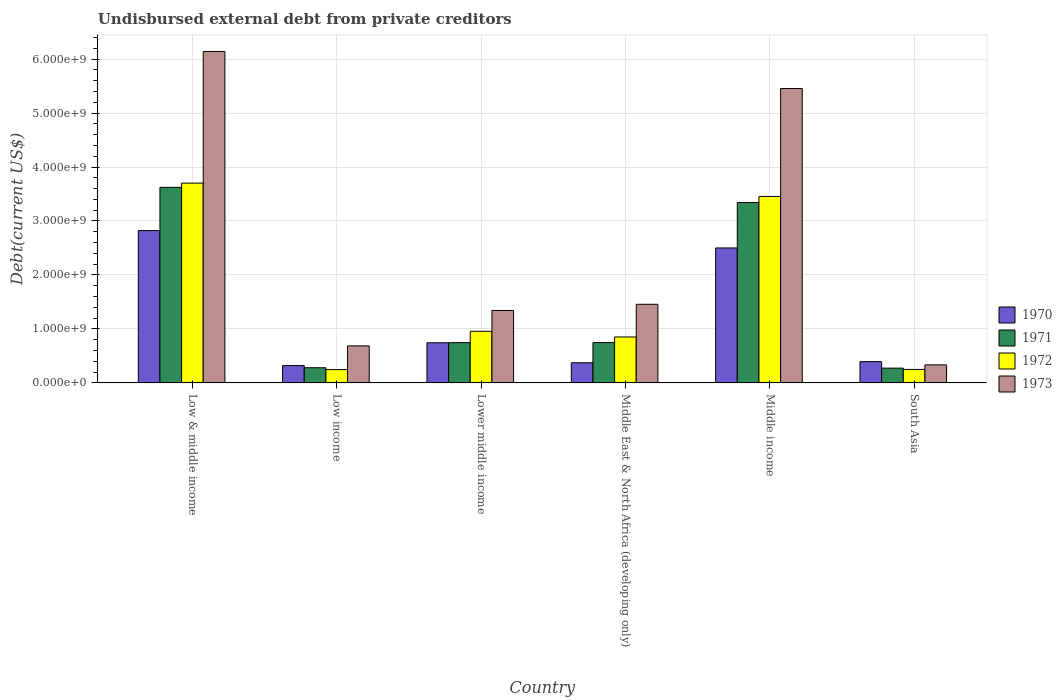How many different coloured bars are there?
Offer a very short reply. 4. How many bars are there on the 5th tick from the left?
Keep it short and to the point. 4. What is the label of the 3rd group of bars from the left?
Ensure brevity in your answer.  Lower middle income. In how many cases, is the number of bars for a given country not equal to the number of legend labels?
Give a very brief answer. 0. What is the total debt in 1972 in Low income?
Offer a terse response. 2.47e+08. Across all countries, what is the maximum total debt in 1973?
Provide a short and direct response. 6.14e+09. Across all countries, what is the minimum total debt in 1971?
Keep it short and to the point. 2.74e+08. In which country was the total debt in 1972 maximum?
Provide a succinct answer. Low & middle income. In which country was the total debt in 1970 minimum?
Offer a very short reply. Low income. What is the total total debt in 1971 in the graph?
Provide a succinct answer. 9.01e+09. What is the difference between the total debt in 1973 in Middle income and that in South Asia?
Your answer should be very brief. 5.12e+09. What is the difference between the total debt in 1971 in Low income and the total debt in 1973 in Middle East & North Africa (developing only)?
Ensure brevity in your answer.  -1.18e+09. What is the average total debt in 1970 per country?
Ensure brevity in your answer.  1.19e+09. What is the difference between the total debt of/in 1970 and total debt of/in 1972 in Low & middle income?
Provide a succinct answer. -8.79e+08. In how many countries, is the total debt in 1971 greater than 2000000000 US$?
Make the answer very short. 2. What is the ratio of the total debt in 1971 in Middle East & North Africa (developing only) to that in South Asia?
Provide a succinct answer. 2.73. Is the total debt in 1972 in Lower middle income less than that in Middle East & North Africa (developing only)?
Make the answer very short. No. What is the difference between the highest and the second highest total debt in 1970?
Your response must be concise. 2.08e+09. What is the difference between the highest and the lowest total debt in 1970?
Keep it short and to the point. 2.50e+09. Is the sum of the total debt in 1971 in Lower middle income and South Asia greater than the maximum total debt in 1972 across all countries?
Give a very brief answer. No. Is it the case that in every country, the sum of the total debt in 1972 and total debt in 1970 is greater than the sum of total debt in 1971 and total debt in 1973?
Your answer should be compact. No. What does the 1st bar from the right in Middle East & North Africa (developing only) represents?
Your answer should be compact. 1973. Is it the case that in every country, the sum of the total debt in 1971 and total debt in 1973 is greater than the total debt in 1972?
Offer a terse response. Yes. Are all the bars in the graph horizontal?
Make the answer very short. No. How many countries are there in the graph?
Provide a succinct answer. 6. Are the values on the major ticks of Y-axis written in scientific E-notation?
Your answer should be very brief. Yes. Does the graph contain grids?
Provide a succinct answer. Yes. What is the title of the graph?
Your response must be concise. Undisbursed external debt from private creditors. Does "1973" appear as one of the legend labels in the graph?
Offer a terse response. Yes. What is the label or title of the X-axis?
Provide a short and direct response. Country. What is the label or title of the Y-axis?
Ensure brevity in your answer.  Debt(current US$). What is the Debt(current US$) in 1970 in Low & middle income?
Provide a succinct answer. 2.82e+09. What is the Debt(current US$) in 1971 in Low & middle income?
Ensure brevity in your answer.  3.62e+09. What is the Debt(current US$) in 1972 in Low & middle income?
Your response must be concise. 3.70e+09. What is the Debt(current US$) of 1973 in Low & middle income?
Your response must be concise. 6.14e+09. What is the Debt(current US$) of 1970 in Low income?
Make the answer very short. 3.22e+08. What is the Debt(current US$) in 1971 in Low income?
Your response must be concise. 2.82e+08. What is the Debt(current US$) of 1972 in Low income?
Provide a short and direct response. 2.47e+08. What is the Debt(current US$) of 1973 in Low income?
Your answer should be very brief. 6.86e+08. What is the Debt(current US$) in 1970 in Lower middle income?
Your answer should be compact. 7.44e+08. What is the Debt(current US$) in 1971 in Lower middle income?
Offer a very short reply. 7.46e+08. What is the Debt(current US$) in 1972 in Lower middle income?
Offer a terse response. 9.57e+08. What is the Debt(current US$) in 1973 in Lower middle income?
Make the answer very short. 1.34e+09. What is the Debt(current US$) in 1970 in Middle East & North Africa (developing only)?
Keep it short and to the point. 3.74e+08. What is the Debt(current US$) of 1971 in Middle East & North Africa (developing only)?
Make the answer very short. 7.48e+08. What is the Debt(current US$) of 1972 in Middle East & North Africa (developing only)?
Make the answer very short. 8.51e+08. What is the Debt(current US$) in 1973 in Middle East & North Africa (developing only)?
Offer a terse response. 1.46e+09. What is the Debt(current US$) in 1970 in Middle income?
Ensure brevity in your answer.  2.50e+09. What is the Debt(current US$) in 1971 in Middle income?
Ensure brevity in your answer.  3.34e+09. What is the Debt(current US$) of 1972 in Middle income?
Your answer should be compact. 3.45e+09. What is the Debt(current US$) of 1973 in Middle income?
Provide a succinct answer. 5.45e+09. What is the Debt(current US$) of 1970 in South Asia?
Provide a succinct answer. 3.94e+08. What is the Debt(current US$) in 1971 in South Asia?
Make the answer very short. 2.74e+08. What is the Debt(current US$) in 1972 in South Asia?
Ensure brevity in your answer.  2.50e+08. What is the Debt(current US$) in 1973 in South Asia?
Your answer should be compact. 3.35e+08. Across all countries, what is the maximum Debt(current US$) in 1970?
Your answer should be compact. 2.82e+09. Across all countries, what is the maximum Debt(current US$) in 1971?
Offer a very short reply. 3.62e+09. Across all countries, what is the maximum Debt(current US$) of 1972?
Keep it short and to the point. 3.70e+09. Across all countries, what is the maximum Debt(current US$) in 1973?
Your response must be concise. 6.14e+09. Across all countries, what is the minimum Debt(current US$) of 1970?
Offer a very short reply. 3.22e+08. Across all countries, what is the minimum Debt(current US$) of 1971?
Ensure brevity in your answer.  2.74e+08. Across all countries, what is the minimum Debt(current US$) of 1972?
Your answer should be very brief. 2.47e+08. Across all countries, what is the minimum Debt(current US$) of 1973?
Ensure brevity in your answer.  3.35e+08. What is the total Debt(current US$) of 1970 in the graph?
Your answer should be compact. 7.16e+09. What is the total Debt(current US$) of 1971 in the graph?
Your answer should be very brief. 9.01e+09. What is the total Debt(current US$) in 1972 in the graph?
Offer a terse response. 9.46e+09. What is the total Debt(current US$) in 1973 in the graph?
Offer a very short reply. 1.54e+1. What is the difference between the Debt(current US$) in 1970 in Low & middle income and that in Low income?
Offer a very short reply. 2.50e+09. What is the difference between the Debt(current US$) in 1971 in Low & middle income and that in Low income?
Make the answer very short. 3.34e+09. What is the difference between the Debt(current US$) in 1972 in Low & middle income and that in Low income?
Your response must be concise. 3.45e+09. What is the difference between the Debt(current US$) of 1973 in Low & middle income and that in Low income?
Give a very brief answer. 5.45e+09. What is the difference between the Debt(current US$) in 1970 in Low & middle income and that in Lower middle income?
Provide a short and direct response. 2.08e+09. What is the difference between the Debt(current US$) of 1971 in Low & middle income and that in Lower middle income?
Offer a very short reply. 2.88e+09. What is the difference between the Debt(current US$) in 1972 in Low & middle income and that in Lower middle income?
Provide a short and direct response. 2.74e+09. What is the difference between the Debt(current US$) in 1973 in Low & middle income and that in Lower middle income?
Give a very brief answer. 4.80e+09. What is the difference between the Debt(current US$) in 1970 in Low & middle income and that in Middle East & North Africa (developing only)?
Provide a short and direct response. 2.45e+09. What is the difference between the Debt(current US$) of 1971 in Low & middle income and that in Middle East & North Africa (developing only)?
Make the answer very short. 2.88e+09. What is the difference between the Debt(current US$) in 1972 in Low & middle income and that in Middle East & North Africa (developing only)?
Your answer should be compact. 2.85e+09. What is the difference between the Debt(current US$) in 1973 in Low & middle income and that in Middle East & North Africa (developing only)?
Keep it short and to the point. 4.68e+09. What is the difference between the Debt(current US$) of 1970 in Low & middle income and that in Middle income?
Offer a very short reply. 3.22e+08. What is the difference between the Debt(current US$) in 1971 in Low & middle income and that in Middle income?
Your answer should be very brief. 2.82e+08. What is the difference between the Debt(current US$) of 1972 in Low & middle income and that in Middle income?
Offer a terse response. 2.47e+08. What is the difference between the Debt(current US$) of 1973 in Low & middle income and that in Middle income?
Make the answer very short. 6.86e+08. What is the difference between the Debt(current US$) in 1970 in Low & middle income and that in South Asia?
Give a very brief answer. 2.43e+09. What is the difference between the Debt(current US$) in 1971 in Low & middle income and that in South Asia?
Provide a short and direct response. 3.35e+09. What is the difference between the Debt(current US$) in 1972 in Low & middle income and that in South Asia?
Your response must be concise. 3.45e+09. What is the difference between the Debt(current US$) of 1973 in Low & middle income and that in South Asia?
Offer a very short reply. 5.81e+09. What is the difference between the Debt(current US$) in 1970 in Low income and that in Lower middle income?
Give a very brief answer. -4.22e+08. What is the difference between the Debt(current US$) of 1971 in Low income and that in Lower middle income?
Keep it short and to the point. -4.65e+08. What is the difference between the Debt(current US$) in 1972 in Low income and that in Lower middle income?
Ensure brevity in your answer.  -7.10e+08. What is the difference between the Debt(current US$) of 1973 in Low income and that in Lower middle income?
Provide a succinct answer. -6.56e+08. What is the difference between the Debt(current US$) of 1970 in Low income and that in Middle East & North Africa (developing only)?
Keep it short and to the point. -5.15e+07. What is the difference between the Debt(current US$) in 1971 in Low income and that in Middle East & North Africa (developing only)?
Provide a succinct answer. -4.66e+08. What is the difference between the Debt(current US$) in 1972 in Low income and that in Middle East & North Africa (developing only)?
Your answer should be very brief. -6.05e+08. What is the difference between the Debt(current US$) of 1973 in Low income and that in Middle East & North Africa (developing only)?
Make the answer very short. -7.71e+08. What is the difference between the Debt(current US$) in 1970 in Low income and that in Middle income?
Ensure brevity in your answer.  -2.18e+09. What is the difference between the Debt(current US$) of 1971 in Low income and that in Middle income?
Provide a succinct answer. -3.06e+09. What is the difference between the Debt(current US$) of 1972 in Low income and that in Middle income?
Make the answer very short. -3.21e+09. What is the difference between the Debt(current US$) in 1973 in Low income and that in Middle income?
Your response must be concise. -4.77e+09. What is the difference between the Debt(current US$) of 1970 in Low income and that in South Asia?
Keep it short and to the point. -7.22e+07. What is the difference between the Debt(current US$) of 1971 in Low income and that in South Asia?
Your answer should be very brief. 7.14e+06. What is the difference between the Debt(current US$) in 1972 in Low income and that in South Asia?
Provide a short and direct response. -3.44e+06. What is the difference between the Debt(current US$) in 1973 in Low income and that in South Asia?
Your answer should be very brief. 3.52e+08. What is the difference between the Debt(current US$) of 1970 in Lower middle income and that in Middle East & North Africa (developing only)?
Provide a short and direct response. 3.71e+08. What is the difference between the Debt(current US$) in 1971 in Lower middle income and that in Middle East & North Africa (developing only)?
Your response must be concise. -1.62e+06. What is the difference between the Debt(current US$) of 1972 in Lower middle income and that in Middle East & North Africa (developing only)?
Provide a succinct answer. 1.05e+08. What is the difference between the Debt(current US$) of 1973 in Lower middle income and that in Middle East & North Africa (developing only)?
Your answer should be very brief. -1.14e+08. What is the difference between the Debt(current US$) in 1970 in Lower middle income and that in Middle income?
Give a very brief answer. -1.76e+09. What is the difference between the Debt(current US$) of 1971 in Lower middle income and that in Middle income?
Your answer should be very brief. -2.60e+09. What is the difference between the Debt(current US$) in 1972 in Lower middle income and that in Middle income?
Offer a terse response. -2.50e+09. What is the difference between the Debt(current US$) in 1973 in Lower middle income and that in Middle income?
Provide a short and direct response. -4.11e+09. What is the difference between the Debt(current US$) of 1970 in Lower middle income and that in South Asia?
Your answer should be compact. 3.50e+08. What is the difference between the Debt(current US$) in 1971 in Lower middle income and that in South Asia?
Your answer should be very brief. 4.72e+08. What is the difference between the Debt(current US$) of 1972 in Lower middle income and that in South Asia?
Provide a short and direct response. 7.07e+08. What is the difference between the Debt(current US$) in 1973 in Lower middle income and that in South Asia?
Offer a very short reply. 1.01e+09. What is the difference between the Debt(current US$) in 1970 in Middle East & North Africa (developing only) and that in Middle income?
Keep it short and to the point. -2.13e+09. What is the difference between the Debt(current US$) in 1971 in Middle East & North Africa (developing only) and that in Middle income?
Offer a terse response. -2.59e+09. What is the difference between the Debt(current US$) of 1972 in Middle East & North Africa (developing only) and that in Middle income?
Your answer should be very brief. -2.60e+09. What is the difference between the Debt(current US$) in 1973 in Middle East & North Africa (developing only) and that in Middle income?
Give a very brief answer. -4.00e+09. What is the difference between the Debt(current US$) of 1970 in Middle East & North Africa (developing only) and that in South Asia?
Give a very brief answer. -2.07e+07. What is the difference between the Debt(current US$) of 1971 in Middle East & North Africa (developing only) and that in South Asia?
Provide a short and direct response. 4.74e+08. What is the difference between the Debt(current US$) of 1972 in Middle East & North Africa (developing only) and that in South Asia?
Provide a succinct answer. 6.01e+08. What is the difference between the Debt(current US$) in 1973 in Middle East & North Africa (developing only) and that in South Asia?
Offer a terse response. 1.12e+09. What is the difference between the Debt(current US$) of 1970 in Middle income and that in South Asia?
Provide a succinct answer. 2.11e+09. What is the difference between the Debt(current US$) in 1971 in Middle income and that in South Asia?
Ensure brevity in your answer.  3.07e+09. What is the difference between the Debt(current US$) in 1972 in Middle income and that in South Asia?
Provide a succinct answer. 3.20e+09. What is the difference between the Debt(current US$) of 1973 in Middle income and that in South Asia?
Your answer should be very brief. 5.12e+09. What is the difference between the Debt(current US$) of 1970 in Low & middle income and the Debt(current US$) of 1971 in Low income?
Keep it short and to the point. 2.54e+09. What is the difference between the Debt(current US$) in 1970 in Low & middle income and the Debt(current US$) in 1972 in Low income?
Your response must be concise. 2.58e+09. What is the difference between the Debt(current US$) in 1970 in Low & middle income and the Debt(current US$) in 1973 in Low income?
Provide a short and direct response. 2.14e+09. What is the difference between the Debt(current US$) of 1971 in Low & middle income and the Debt(current US$) of 1972 in Low income?
Your answer should be very brief. 3.38e+09. What is the difference between the Debt(current US$) of 1971 in Low & middle income and the Debt(current US$) of 1973 in Low income?
Make the answer very short. 2.94e+09. What is the difference between the Debt(current US$) of 1972 in Low & middle income and the Debt(current US$) of 1973 in Low income?
Provide a succinct answer. 3.02e+09. What is the difference between the Debt(current US$) in 1970 in Low & middle income and the Debt(current US$) in 1971 in Lower middle income?
Your response must be concise. 2.08e+09. What is the difference between the Debt(current US$) of 1970 in Low & middle income and the Debt(current US$) of 1972 in Lower middle income?
Provide a succinct answer. 1.87e+09. What is the difference between the Debt(current US$) of 1970 in Low & middle income and the Debt(current US$) of 1973 in Lower middle income?
Ensure brevity in your answer.  1.48e+09. What is the difference between the Debt(current US$) of 1971 in Low & middle income and the Debt(current US$) of 1972 in Lower middle income?
Provide a short and direct response. 2.67e+09. What is the difference between the Debt(current US$) in 1971 in Low & middle income and the Debt(current US$) in 1973 in Lower middle income?
Your answer should be very brief. 2.28e+09. What is the difference between the Debt(current US$) of 1972 in Low & middle income and the Debt(current US$) of 1973 in Lower middle income?
Make the answer very short. 2.36e+09. What is the difference between the Debt(current US$) in 1970 in Low & middle income and the Debt(current US$) in 1971 in Middle East & North Africa (developing only)?
Your answer should be compact. 2.07e+09. What is the difference between the Debt(current US$) in 1970 in Low & middle income and the Debt(current US$) in 1972 in Middle East & North Africa (developing only)?
Offer a terse response. 1.97e+09. What is the difference between the Debt(current US$) of 1970 in Low & middle income and the Debt(current US$) of 1973 in Middle East & North Africa (developing only)?
Your answer should be very brief. 1.37e+09. What is the difference between the Debt(current US$) in 1971 in Low & middle income and the Debt(current US$) in 1972 in Middle East & North Africa (developing only)?
Offer a very short reply. 2.77e+09. What is the difference between the Debt(current US$) of 1971 in Low & middle income and the Debt(current US$) of 1973 in Middle East & North Africa (developing only)?
Offer a terse response. 2.17e+09. What is the difference between the Debt(current US$) in 1972 in Low & middle income and the Debt(current US$) in 1973 in Middle East & North Africa (developing only)?
Ensure brevity in your answer.  2.24e+09. What is the difference between the Debt(current US$) in 1970 in Low & middle income and the Debt(current US$) in 1971 in Middle income?
Offer a terse response. -5.19e+08. What is the difference between the Debt(current US$) of 1970 in Low & middle income and the Debt(current US$) of 1972 in Middle income?
Offer a terse response. -6.32e+08. What is the difference between the Debt(current US$) of 1970 in Low & middle income and the Debt(current US$) of 1973 in Middle income?
Keep it short and to the point. -2.63e+09. What is the difference between the Debt(current US$) in 1971 in Low & middle income and the Debt(current US$) in 1972 in Middle income?
Make the answer very short. 1.68e+08. What is the difference between the Debt(current US$) of 1971 in Low & middle income and the Debt(current US$) of 1973 in Middle income?
Give a very brief answer. -1.83e+09. What is the difference between the Debt(current US$) in 1972 in Low & middle income and the Debt(current US$) in 1973 in Middle income?
Your answer should be compact. -1.75e+09. What is the difference between the Debt(current US$) in 1970 in Low & middle income and the Debt(current US$) in 1971 in South Asia?
Give a very brief answer. 2.55e+09. What is the difference between the Debt(current US$) in 1970 in Low & middle income and the Debt(current US$) in 1972 in South Asia?
Provide a succinct answer. 2.57e+09. What is the difference between the Debt(current US$) in 1970 in Low & middle income and the Debt(current US$) in 1973 in South Asia?
Ensure brevity in your answer.  2.49e+09. What is the difference between the Debt(current US$) of 1971 in Low & middle income and the Debt(current US$) of 1972 in South Asia?
Ensure brevity in your answer.  3.37e+09. What is the difference between the Debt(current US$) of 1971 in Low & middle income and the Debt(current US$) of 1973 in South Asia?
Your answer should be compact. 3.29e+09. What is the difference between the Debt(current US$) of 1972 in Low & middle income and the Debt(current US$) of 1973 in South Asia?
Your response must be concise. 3.37e+09. What is the difference between the Debt(current US$) of 1970 in Low income and the Debt(current US$) of 1971 in Lower middle income?
Your answer should be compact. -4.24e+08. What is the difference between the Debt(current US$) in 1970 in Low income and the Debt(current US$) in 1972 in Lower middle income?
Ensure brevity in your answer.  -6.35e+08. What is the difference between the Debt(current US$) in 1970 in Low income and the Debt(current US$) in 1973 in Lower middle income?
Give a very brief answer. -1.02e+09. What is the difference between the Debt(current US$) of 1971 in Low income and the Debt(current US$) of 1972 in Lower middle income?
Give a very brief answer. -6.75e+08. What is the difference between the Debt(current US$) in 1971 in Low income and the Debt(current US$) in 1973 in Lower middle income?
Offer a terse response. -1.06e+09. What is the difference between the Debt(current US$) of 1972 in Low income and the Debt(current US$) of 1973 in Lower middle income?
Make the answer very short. -1.10e+09. What is the difference between the Debt(current US$) in 1970 in Low income and the Debt(current US$) in 1971 in Middle East & North Africa (developing only)?
Keep it short and to the point. -4.26e+08. What is the difference between the Debt(current US$) of 1970 in Low income and the Debt(current US$) of 1972 in Middle East & North Africa (developing only)?
Keep it short and to the point. -5.29e+08. What is the difference between the Debt(current US$) of 1970 in Low income and the Debt(current US$) of 1973 in Middle East & North Africa (developing only)?
Your answer should be very brief. -1.13e+09. What is the difference between the Debt(current US$) in 1971 in Low income and the Debt(current US$) in 1972 in Middle East & North Africa (developing only)?
Ensure brevity in your answer.  -5.70e+08. What is the difference between the Debt(current US$) in 1971 in Low income and the Debt(current US$) in 1973 in Middle East & North Africa (developing only)?
Make the answer very short. -1.18e+09. What is the difference between the Debt(current US$) in 1972 in Low income and the Debt(current US$) in 1973 in Middle East & North Africa (developing only)?
Your answer should be compact. -1.21e+09. What is the difference between the Debt(current US$) of 1970 in Low income and the Debt(current US$) of 1971 in Middle income?
Keep it short and to the point. -3.02e+09. What is the difference between the Debt(current US$) in 1970 in Low income and the Debt(current US$) in 1972 in Middle income?
Ensure brevity in your answer.  -3.13e+09. What is the difference between the Debt(current US$) of 1970 in Low income and the Debt(current US$) of 1973 in Middle income?
Make the answer very short. -5.13e+09. What is the difference between the Debt(current US$) of 1971 in Low income and the Debt(current US$) of 1972 in Middle income?
Give a very brief answer. -3.17e+09. What is the difference between the Debt(current US$) of 1971 in Low income and the Debt(current US$) of 1973 in Middle income?
Your answer should be very brief. -5.17e+09. What is the difference between the Debt(current US$) of 1972 in Low income and the Debt(current US$) of 1973 in Middle income?
Ensure brevity in your answer.  -5.21e+09. What is the difference between the Debt(current US$) in 1970 in Low income and the Debt(current US$) in 1971 in South Asia?
Provide a succinct answer. 4.77e+07. What is the difference between the Debt(current US$) in 1970 in Low income and the Debt(current US$) in 1972 in South Asia?
Ensure brevity in your answer.  7.18e+07. What is the difference between the Debt(current US$) of 1970 in Low income and the Debt(current US$) of 1973 in South Asia?
Provide a succinct answer. -1.27e+07. What is the difference between the Debt(current US$) of 1971 in Low income and the Debt(current US$) of 1972 in South Asia?
Provide a succinct answer. 3.13e+07. What is the difference between the Debt(current US$) in 1971 in Low income and the Debt(current US$) in 1973 in South Asia?
Offer a very short reply. -5.33e+07. What is the difference between the Debt(current US$) in 1972 in Low income and the Debt(current US$) in 1973 in South Asia?
Offer a terse response. -8.80e+07. What is the difference between the Debt(current US$) of 1970 in Lower middle income and the Debt(current US$) of 1971 in Middle East & North Africa (developing only)?
Give a very brief answer. -3.71e+06. What is the difference between the Debt(current US$) in 1970 in Lower middle income and the Debt(current US$) in 1972 in Middle East & North Africa (developing only)?
Offer a terse response. -1.07e+08. What is the difference between the Debt(current US$) of 1970 in Lower middle income and the Debt(current US$) of 1973 in Middle East & North Africa (developing only)?
Your answer should be compact. -7.13e+08. What is the difference between the Debt(current US$) of 1971 in Lower middle income and the Debt(current US$) of 1972 in Middle East & North Africa (developing only)?
Provide a short and direct response. -1.05e+08. What is the difference between the Debt(current US$) of 1971 in Lower middle income and the Debt(current US$) of 1973 in Middle East & North Africa (developing only)?
Your answer should be compact. -7.11e+08. What is the difference between the Debt(current US$) in 1972 in Lower middle income and the Debt(current US$) in 1973 in Middle East & North Africa (developing only)?
Your response must be concise. -5.00e+08. What is the difference between the Debt(current US$) in 1970 in Lower middle income and the Debt(current US$) in 1971 in Middle income?
Make the answer very short. -2.60e+09. What is the difference between the Debt(current US$) of 1970 in Lower middle income and the Debt(current US$) of 1972 in Middle income?
Your answer should be compact. -2.71e+09. What is the difference between the Debt(current US$) of 1970 in Lower middle income and the Debt(current US$) of 1973 in Middle income?
Your response must be concise. -4.71e+09. What is the difference between the Debt(current US$) in 1971 in Lower middle income and the Debt(current US$) in 1972 in Middle income?
Ensure brevity in your answer.  -2.71e+09. What is the difference between the Debt(current US$) of 1971 in Lower middle income and the Debt(current US$) of 1973 in Middle income?
Ensure brevity in your answer.  -4.71e+09. What is the difference between the Debt(current US$) in 1972 in Lower middle income and the Debt(current US$) in 1973 in Middle income?
Make the answer very short. -4.50e+09. What is the difference between the Debt(current US$) in 1970 in Lower middle income and the Debt(current US$) in 1971 in South Asia?
Make the answer very short. 4.70e+08. What is the difference between the Debt(current US$) of 1970 in Lower middle income and the Debt(current US$) of 1972 in South Asia?
Your answer should be compact. 4.94e+08. What is the difference between the Debt(current US$) of 1970 in Lower middle income and the Debt(current US$) of 1973 in South Asia?
Make the answer very short. 4.09e+08. What is the difference between the Debt(current US$) of 1971 in Lower middle income and the Debt(current US$) of 1972 in South Asia?
Ensure brevity in your answer.  4.96e+08. What is the difference between the Debt(current US$) of 1971 in Lower middle income and the Debt(current US$) of 1973 in South Asia?
Ensure brevity in your answer.  4.11e+08. What is the difference between the Debt(current US$) in 1972 in Lower middle income and the Debt(current US$) in 1973 in South Asia?
Ensure brevity in your answer.  6.22e+08. What is the difference between the Debt(current US$) of 1970 in Middle East & North Africa (developing only) and the Debt(current US$) of 1971 in Middle income?
Your response must be concise. -2.97e+09. What is the difference between the Debt(current US$) of 1970 in Middle East & North Africa (developing only) and the Debt(current US$) of 1972 in Middle income?
Provide a succinct answer. -3.08e+09. What is the difference between the Debt(current US$) of 1970 in Middle East & North Africa (developing only) and the Debt(current US$) of 1973 in Middle income?
Provide a succinct answer. -5.08e+09. What is the difference between the Debt(current US$) in 1971 in Middle East & North Africa (developing only) and the Debt(current US$) in 1972 in Middle income?
Give a very brief answer. -2.71e+09. What is the difference between the Debt(current US$) in 1971 in Middle East & North Africa (developing only) and the Debt(current US$) in 1973 in Middle income?
Make the answer very short. -4.71e+09. What is the difference between the Debt(current US$) of 1972 in Middle East & North Africa (developing only) and the Debt(current US$) of 1973 in Middle income?
Your answer should be compact. -4.60e+09. What is the difference between the Debt(current US$) in 1970 in Middle East & North Africa (developing only) and the Debt(current US$) in 1971 in South Asia?
Your response must be concise. 9.92e+07. What is the difference between the Debt(current US$) in 1970 in Middle East & North Africa (developing only) and the Debt(current US$) in 1972 in South Asia?
Provide a succinct answer. 1.23e+08. What is the difference between the Debt(current US$) of 1970 in Middle East & North Africa (developing only) and the Debt(current US$) of 1973 in South Asia?
Keep it short and to the point. 3.88e+07. What is the difference between the Debt(current US$) in 1971 in Middle East & North Africa (developing only) and the Debt(current US$) in 1972 in South Asia?
Offer a terse response. 4.98e+08. What is the difference between the Debt(current US$) in 1971 in Middle East & North Africa (developing only) and the Debt(current US$) in 1973 in South Asia?
Give a very brief answer. 4.13e+08. What is the difference between the Debt(current US$) of 1972 in Middle East & North Africa (developing only) and the Debt(current US$) of 1973 in South Asia?
Make the answer very short. 5.17e+08. What is the difference between the Debt(current US$) in 1970 in Middle income and the Debt(current US$) in 1971 in South Asia?
Your answer should be very brief. 2.23e+09. What is the difference between the Debt(current US$) of 1970 in Middle income and the Debt(current US$) of 1972 in South Asia?
Offer a terse response. 2.25e+09. What is the difference between the Debt(current US$) of 1970 in Middle income and the Debt(current US$) of 1973 in South Asia?
Provide a succinct answer. 2.17e+09. What is the difference between the Debt(current US$) of 1971 in Middle income and the Debt(current US$) of 1972 in South Asia?
Your response must be concise. 3.09e+09. What is the difference between the Debt(current US$) of 1971 in Middle income and the Debt(current US$) of 1973 in South Asia?
Your answer should be compact. 3.01e+09. What is the difference between the Debt(current US$) of 1972 in Middle income and the Debt(current US$) of 1973 in South Asia?
Make the answer very short. 3.12e+09. What is the average Debt(current US$) in 1970 per country?
Ensure brevity in your answer.  1.19e+09. What is the average Debt(current US$) in 1971 per country?
Give a very brief answer. 1.50e+09. What is the average Debt(current US$) in 1972 per country?
Offer a terse response. 1.58e+09. What is the average Debt(current US$) in 1973 per country?
Provide a succinct answer. 2.57e+09. What is the difference between the Debt(current US$) of 1970 and Debt(current US$) of 1971 in Low & middle income?
Give a very brief answer. -8.01e+08. What is the difference between the Debt(current US$) of 1970 and Debt(current US$) of 1972 in Low & middle income?
Give a very brief answer. -8.79e+08. What is the difference between the Debt(current US$) of 1970 and Debt(current US$) of 1973 in Low & middle income?
Give a very brief answer. -3.32e+09. What is the difference between the Debt(current US$) of 1971 and Debt(current US$) of 1972 in Low & middle income?
Give a very brief answer. -7.84e+07. What is the difference between the Debt(current US$) in 1971 and Debt(current US$) in 1973 in Low & middle income?
Keep it short and to the point. -2.52e+09. What is the difference between the Debt(current US$) of 1972 and Debt(current US$) of 1973 in Low & middle income?
Provide a succinct answer. -2.44e+09. What is the difference between the Debt(current US$) in 1970 and Debt(current US$) in 1971 in Low income?
Offer a terse response. 4.06e+07. What is the difference between the Debt(current US$) in 1970 and Debt(current US$) in 1972 in Low income?
Your answer should be very brief. 7.53e+07. What is the difference between the Debt(current US$) in 1970 and Debt(current US$) in 1973 in Low income?
Provide a succinct answer. -3.64e+08. What is the difference between the Debt(current US$) of 1971 and Debt(current US$) of 1972 in Low income?
Offer a very short reply. 3.47e+07. What is the difference between the Debt(current US$) in 1971 and Debt(current US$) in 1973 in Low income?
Ensure brevity in your answer.  -4.05e+08. What is the difference between the Debt(current US$) in 1972 and Debt(current US$) in 1973 in Low income?
Make the answer very short. -4.40e+08. What is the difference between the Debt(current US$) of 1970 and Debt(current US$) of 1971 in Lower middle income?
Ensure brevity in your answer.  -2.10e+06. What is the difference between the Debt(current US$) in 1970 and Debt(current US$) in 1972 in Lower middle income?
Your answer should be very brief. -2.13e+08. What is the difference between the Debt(current US$) of 1970 and Debt(current US$) of 1973 in Lower middle income?
Ensure brevity in your answer.  -5.99e+08. What is the difference between the Debt(current US$) in 1971 and Debt(current US$) in 1972 in Lower middle income?
Give a very brief answer. -2.11e+08. What is the difference between the Debt(current US$) of 1971 and Debt(current US$) of 1973 in Lower middle income?
Ensure brevity in your answer.  -5.97e+08. What is the difference between the Debt(current US$) in 1972 and Debt(current US$) in 1973 in Lower middle income?
Offer a terse response. -3.86e+08. What is the difference between the Debt(current US$) in 1970 and Debt(current US$) in 1971 in Middle East & North Africa (developing only)?
Your answer should be very brief. -3.74e+08. What is the difference between the Debt(current US$) of 1970 and Debt(current US$) of 1972 in Middle East & North Africa (developing only)?
Provide a short and direct response. -4.78e+08. What is the difference between the Debt(current US$) in 1970 and Debt(current US$) in 1973 in Middle East & North Africa (developing only)?
Make the answer very short. -1.08e+09. What is the difference between the Debt(current US$) in 1971 and Debt(current US$) in 1972 in Middle East & North Africa (developing only)?
Offer a terse response. -1.04e+08. What is the difference between the Debt(current US$) of 1971 and Debt(current US$) of 1973 in Middle East & North Africa (developing only)?
Make the answer very short. -7.09e+08. What is the difference between the Debt(current US$) of 1972 and Debt(current US$) of 1973 in Middle East & North Africa (developing only)?
Give a very brief answer. -6.06e+08. What is the difference between the Debt(current US$) in 1970 and Debt(current US$) in 1971 in Middle income?
Offer a terse response. -8.41e+08. What is the difference between the Debt(current US$) of 1970 and Debt(current US$) of 1972 in Middle income?
Make the answer very short. -9.54e+08. What is the difference between the Debt(current US$) of 1970 and Debt(current US$) of 1973 in Middle income?
Keep it short and to the point. -2.95e+09. What is the difference between the Debt(current US$) in 1971 and Debt(current US$) in 1972 in Middle income?
Offer a terse response. -1.13e+08. What is the difference between the Debt(current US$) in 1971 and Debt(current US$) in 1973 in Middle income?
Ensure brevity in your answer.  -2.11e+09. What is the difference between the Debt(current US$) in 1972 and Debt(current US$) in 1973 in Middle income?
Make the answer very short. -2.00e+09. What is the difference between the Debt(current US$) in 1970 and Debt(current US$) in 1971 in South Asia?
Offer a terse response. 1.20e+08. What is the difference between the Debt(current US$) of 1970 and Debt(current US$) of 1972 in South Asia?
Your answer should be very brief. 1.44e+08. What is the difference between the Debt(current US$) of 1970 and Debt(current US$) of 1973 in South Asia?
Your response must be concise. 5.95e+07. What is the difference between the Debt(current US$) of 1971 and Debt(current US$) of 1972 in South Asia?
Your answer should be very brief. 2.41e+07. What is the difference between the Debt(current US$) in 1971 and Debt(current US$) in 1973 in South Asia?
Ensure brevity in your answer.  -6.04e+07. What is the difference between the Debt(current US$) of 1972 and Debt(current US$) of 1973 in South Asia?
Your response must be concise. -8.45e+07. What is the ratio of the Debt(current US$) of 1970 in Low & middle income to that in Low income?
Offer a very short reply. 8.76. What is the ratio of the Debt(current US$) in 1971 in Low & middle income to that in Low income?
Offer a very short reply. 12.87. What is the ratio of the Debt(current US$) of 1972 in Low & middle income to that in Low income?
Keep it short and to the point. 15. What is the ratio of the Debt(current US$) in 1973 in Low & middle income to that in Low income?
Ensure brevity in your answer.  8.95. What is the ratio of the Debt(current US$) of 1970 in Low & middle income to that in Lower middle income?
Your answer should be compact. 3.79. What is the ratio of the Debt(current US$) in 1971 in Low & middle income to that in Lower middle income?
Your response must be concise. 4.86. What is the ratio of the Debt(current US$) of 1972 in Low & middle income to that in Lower middle income?
Give a very brief answer. 3.87. What is the ratio of the Debt(current US$) in 1973 in Low & middle income to that in Lower middle income?
Ensure brevity in your answer.  4.57. What is the ratio of the Debt(current US$) of 1970 in Low & middle income to that in Middle East & North Africa (developing only)?
Keep it short and to the point. 7.55. What is the ratio of the Debt(current US$) in 1971 in Low & middle income to that in Middle East & North Africa (developing only)?
Ensure brevity in your answer.  4.84. What is the ratio of the Debt(current US$) in 1972 in Low & middle income to that in Middle East & North Africa (developing only)?
Make the answer very short. 4.35. What is the ratio of the Debt(current US$) in 1973 in Low & middle income to that in Middle East & North Africa (developing only)?
Ensure brevity in your answer.  4.21. What is the ratio of the Debt(current US$) in 1970 in Low & middle income to that in Middle income?
Offer a terse response. 1.13. What is the ratio of the Debt(current US$) of 1971 in Low & middle income to that in Middle income?
Your answer should be very brief. 1.08. What is the ratio of the Debt(current US$) of 1972 in Low & middle income to that in Middle income?
Offer a terse response. 1.07. What is the ratio of the Debt(current US$) of 1973 in Low & middle income to that in Middle income?
Ensure brevity in your answer.  1.13. What is the ratio of the Debt(current US$) of 1970 in Low & middle income to that in South Asia?
Offer a terse response. 7.16. What is the ratio of the Debt(current US$) of 1971 in Low & middle income to that in South Asia?
Your answer should be very brief. 13.2. What is the ratio of the Debt(current US$) in 1972 in Low & middle income to that in South Asia?
Give a very brief answer. 14.79. What is the ratio of the Debt(current US$) of 1973 in Low & middle income to that in South Asia?
Your response must be concise. 18.34. What is the ratio of the Debt(current US$) in 1970 in Low income to that in Lower middle income?
Ensure brevity in your answer.  0.43. What is the ratio of the Debt(current US$) of 1971 in Low income to that in Lower middle income?
Your answer should be compact. 0.38. What is the ratio of the Debt(current US$) of 1972 in Low income to that in Lower middle income?
Your answer should be compact. 0.26. What is the ratio of the Debt(current US$) in 1973 in Low income to that in Lower middle income?
Ensure brevity in your answer.  0.51. What is the ratio of the Debt(current US$) in 1970 in Low income to that in Middle East & North Africa (developing only)?
Your answer should be very brief. 0.86. What is the ratio of the Debt(current US$) of 1971 in Low income to that in Middle East & North Africa (developing only)?
Ensure brevity in your answer.  0.38. What is the ratio of the Debt(current US$) in 1972 in Low income to that in Middle East & North Africa (developing only)?
Keep it short and to the point. 0.29. What is the ratio of the Debt(current US$) in 1973 in Low income to that in Middle East & North Africa (developing only)?
Give a very brief answer. 0.47. What is the ratio of the Debt(current US$) in 1970 in Low income to that in Middle income?
Your response must be concise. 0.13. What is the ratio of the Debt(current US$) of 1971 in Low income to that in Middle income?
Provide a succinct answer. 0.08. What is the ratio of the Debt(current US$) in 1972 in Low income to that in Middle income?
Ensure brevity in your answer.  0.07. What is the ratio of the Debt(current US$) of 1973 in Low income to that in Middle income?
Provide a short and direct response. 0.13. What is the ratio of the Debt(current US$) in 1970 in Low income to that in South Asia?
Provide a short and direct response. 0.82. What is the ratio of the Debt(current US$) of 1971 in Low income to that in South Asia?
Keep it short and to the point. 1.03. What is the ratio of the Debt(current US$) of 1972 in Low income to that in South Asia?
Provide a short and direct response. 0.99. What is the ratio of the Debt(current US$) of 1973 in Low income to that in South Asia?
Offer a very short reply. 2.05. What is the ratio of the Debt(current US$) of 1970 in Lower middle income to that in Middle East & North Africa (developing only)?
Make the answer very short. 1.99. What is the ratio of the Debt(current US$) of 1972 in Lower middle income to that in Middle East & North Africa (developing only)?
Provide a succinct answer. 1.12. What is the ratio of the Debt(current US$) in 1973 in Lower middle income to that in Middle East & North Africa (developing only)?
Ensure brevity in your answer.  0.92. What is the ratio of the Debt(current US$) in 1970 in Lower middle income to that in Middle income?
Make the answer very short. 0.3. What is the ratio of the Debt(current US$) of 1971 in Lower middle income to that in Middle income?
Your answer should be very brief. 0.22. What is the ratio of the Debt(current US$) in 1972 in Lower middle income to that in Middle income?
Provide a short and direct response. 0.28. What is the ratio of the Debt(current US$) of 1973 in Lower middle income to that in Middle income?
Your answer should be very brief. 0.25. What is the ratio of the Debt(current US$) in 1970 in Lower middle income to that in South Asia?
Your response must be concise. 1.89. What is the ratio of the Debt(current US$) in 1971 in Lower middle income to that in South Asia?
Make the answer very short. 2.72. What is the ratio of the Debt(current US$) in 1972 in Lower middle income to that in South Asia?
Provide a short and direct response. 3.82. What is the ratio of the Debt(current US$) of 1973 in Lower middle income to that in South Asia?
Your answer should be compact. 4.01. What is the ratio of the Debt(current US$) of 1970 in Middle East & North Africa (developing only) to that in Middle income?
Offer a very short reply. 0.15. What is the ratio of the Debt(current US$) in 1971 in Middle East & North Africa (developing only) to that in Middle income?
Your response must be concise. 0.22. What is the ratio of the Debt(current US$) in 1972 in Middle East & North Africa (developing only) to that in Middle income?
Provide a short and direct response. 0.25. What is the ratio of the Debt(current US$) of 1973 in Middle East & North Africa (developing only) to that in Middle income?
Your response must be concise. 0.27. What is the ratio of the Debt(current US$) of 1970 in Middle East & North Africa (developing only) to that in South Asia?
Keep it short and to the point. 0.95. What is the ratio of the Debt(current US$) in 1971 in Middle East & North Africa (developing only) to that in South Asia?
Ensure brevity in your answer.  2.73. What is the ratio of the Debt(current US$) of 1972 in Middle East & North Africa (developing only) to that in South Asia?
Give a very brief answer. 3.4. What is the ratio of the Debt(current US$) of 1973 in Middle East & North Africa (developing only) to that in South Asia?
Provide a short and direct response. 4.35. What is the ratio of the Debt(current US$) of 1970 in Middle income to that in South Asia?
Your response must be concise. 6.34. What is the ratio of the Debt(current US$) in 1971 in Middle income to that in South Asia?
Offer a very short reply. 12.18. What is the ratio of the Debt(current US$) in 1972 in Middle income to that in South Asia?
Offer a terse response. 13.8. What is the ratio of the Debt(current US$) of 1973 in Middle income to that in South Asia?
Give a very brief answer. 16.29. What is the difference between the highest and the second highest Debt(current US$) of 1970?
Make the answer very short. 3.22e+08. What is the difference between the highest and the second highest Debt(current US$) of 1971?
Keep it short and to the point. 2.82e+08. What is the difference between the highest and the second highest Debt(current US$) of 1972?
Keep it short and to the point. 2.47e+08. What is the difference between the highest and the second highest Debt(current US$) of 1973?
Provide a succinct answer. 6.86e+08. What is the difference between the highest and the lowest Debt(current US$) of 1970?
Keep it short and to the point. 2.50e+09. What is the difference between the highest and the lowest Debt(current US$) in 1971?
Offer a very short reply. 3.35e+09. What is the difference between the highest and the lowest Debt(current US$) in 1972?
Ensure brevity in your answer.  3.45e+09. What is the difference between the highest and the lowest Debt(current US$) of 1973?
Give a very brief answer. 5.81e+09. 